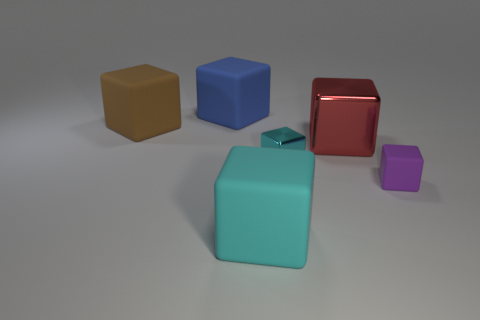Is there anything else that is the same shape as the large cyan matte thing?
Keep it short and to the point. Yes. What number of spheres are either small cyan matte objects or cyan matte objects?
Ensure brevity in your answer.  0. What number of small gray rubber balls are there?
Make the answer very short. 0. How big is the metallic thing that is behind the metal block on the left side of the red thing?
Offer a very short reply. Large. How many other objects are the same size as the brown cube?
Your response must be concise. 3. There is a big red shiny object; what number of rubber objects are behind it?
Give a very brief answer. 2. The red metallic cube is what size?
Provide a succinct answer. Large. Is the material of the cyan thing that is behind the large cyan object the same as the cube to the left of the blue rubber thing?
Your answer should be compact. No. Are there any other objects of the same color as the small matte object?
Make the answer very short. No. What is the color of the metal block that is the same size as the brown matte block?
Your response must be concise. Red. 